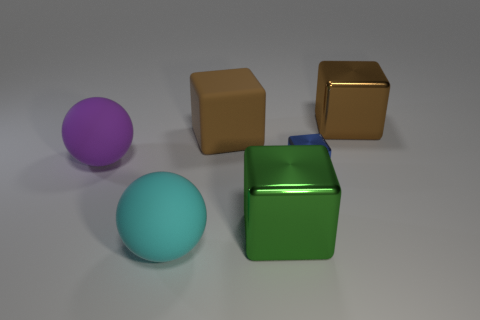Do the matte sphere in front of the blue metallic block and the small metallic thing have the same size?
Give a very brief answer. No. There is a big purple object; what number of tiny cubes are in front of it?
Your response must be concise. 1. What is the material of the object that is on the left side of the green cube and in front of the tiny thing?
Make the answer very short. Rubber. How many tiny things are either brown matte cubes or green shiny blocks?
Your answer should be very brief. 0. How big is the cyan sphere?
Your response must be concise. Large. What is the shape of the big purple rubber object?
Offer a terse response. Sphere. Are there any other things that are the same shape as the large green metallic object?
Offer a very short reply. Yes. Is the number of large brown metallic blocks that are behind the small blue shiny thing less than the number of large cyan things?
Ensure brevity in your answer.  No. Does the big metal cube that is behind the big purple matte thing have the same color as the tiny metallic object?
Your answer should be compact. No. How many rubber objects are either gray balls or large objects?
Make the answer very short. 3. 